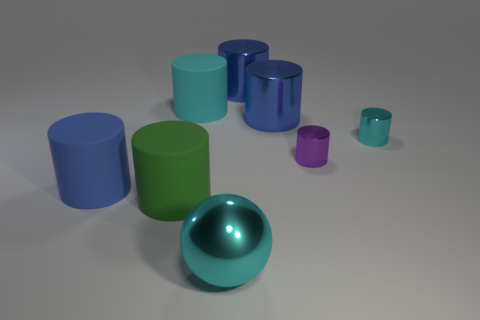Subtract all gray balls. How many blue cylinders are left? 3 Subtract all green cylinders. How many cylinders are left? 6 Subtract 4 cylinders. How many cylinders are left? 3 Subtract all blue cylinders. How many cylinders are left? 4 Subtract all red cylinders. Subtract all green balls. How many cylinders are left? 7 Add 2 green cylinders. How many objects exist? 10 Subtract all cylinders. How many objects are left? 1 Subtract all large brown shiny spheres. Subtract all cyan balls. How many objects are left? 7 Add 7 purple cylinders. How many purple cylinders are left? 8 Add 3 big objects. How many big objects exist? 9 